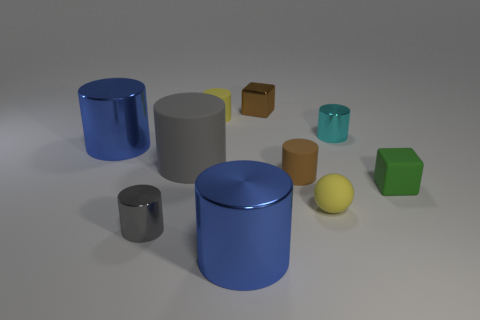Subtract all small cyan metal cylinders. How many cylinders are left? 6 Subtract all yellow cylinders. How many cylinders are left? 6 Subtract 1 spheres. How many spheres are left? 0 Subtract all balls. How many objects are left? 9 Subtract all purple spheres. Subtract all gray blocks. How many spheres are left? 1 Subtract all blue cylinders. How many brown cubes are left? 1 Subtract all small rubber things. Subtract all small green blocks. How many objects are left? 5 Add 9 small metallic cubes. How many small metallic cubes are left? 10 Add 10 large metallic blocks. How many large metallic blocks exist? 10 Subtract 0 red blocks. How many objects are left? 10 